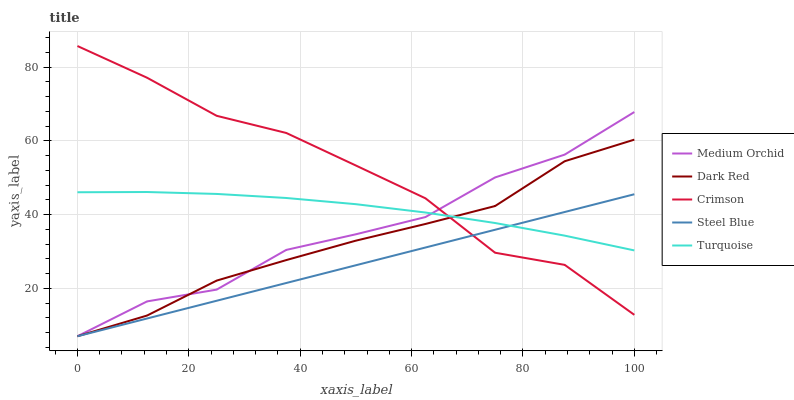Does Dark Red have the minimum area under the curve?
Answer yes or no. No. Does Dark Red have the maximum area under the curve?
Answer yes or no. No. Is Dark Red the smoothest?
Answer yes or no. No. Is Dark Red the roughest?
Answer yes or no. No. Does Turquoise have the lowest value?
Answer yes or no. No. Does Dark Red have the highest value?
Answer yes or no. No. 